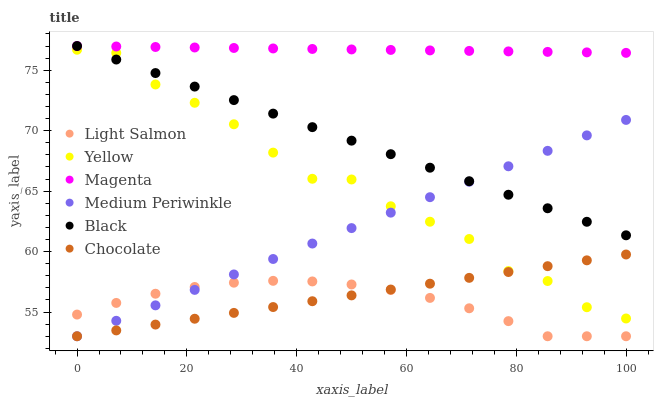Does Light Salmon have the minimum area under the curve?
Answer yes or no. Yes. Does Magenta have the maximum area under the curve?
Answer yes or no. Yes. Does Medium Periwinkle have the minimum area under the curve?
Answer yes or no. No. Does Medium Periwinkle have the maximum area under the curve?
Answer yes or no. No. Is Black the smoothest?
Answer yes or no. Yes. Is Yellow the roughest?
Answer yes or no. Yes. Is Medium Periwinkle the smoothest?
Answer yes or no. No. Is Medium Periwinkle the roughest?
Answer yes or no. No. Does Light Salmon have the lowest value?
Answer yes or no. Yes. Does Yellow have the lowest value?
Answer yes or no. No. Does Magenta have the highest value?
Answer yes or no. Yes. Does Medium Periwinkle have the highest value?
Answer yes or no. No. Is Yellow less than Magenta?
Answer yes or no. Yes. Is Magenta greater than Light Salmon?
Answer yes or no. Yes. Does Black intersect Yellow?
Answer yes or no. Yes. Is Black less than Yellow?
Answer yes or no. No. Is Black greater than Yellow?
Answer yes or no. No. Does Yellow intersect Magenta?
Answer yes or no. No. 